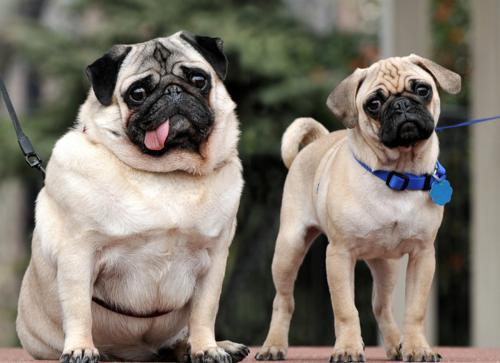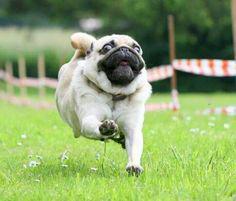The first image is the image on the left, the second image is the image on the right. Assess this claim about the two images: "There is at least one black pug running through the grass.". Correct or not? Answer yes or no. No. The first image is the image on the left, the second image is the image on the right. Assess this claim about the two images: "A white/beige colored pug has been caught on camera with his tongue out.". Correct or not? Answer yes or no. Yes. 